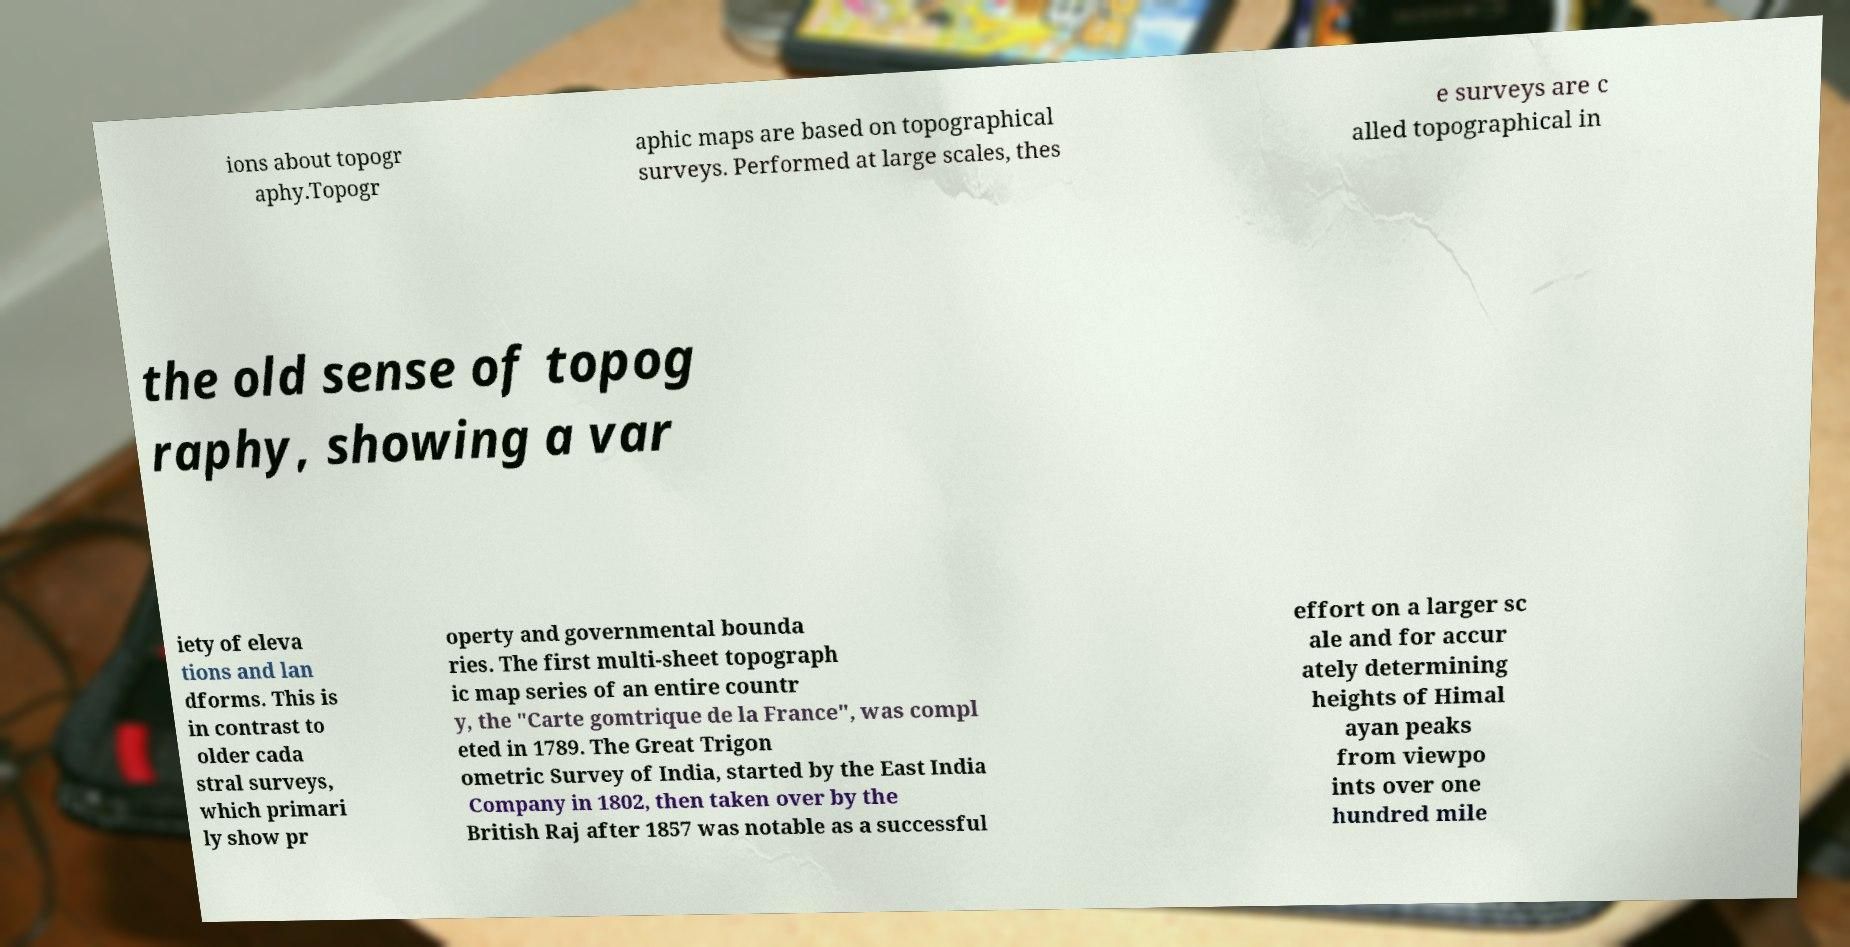Please identify and transcribe the text found in this image. ions about topogr aphy.Topogr aphic maps are based on topographical surveys. Performed at large scales, thes e surveys are c alled topographical in the old sense of topog raphy, showing a var iety of eleva tions and lan dforms. This is in contrast to older cada stral surveys, which primari ly show pr operty and governmental bounda ries. The first multi-sheet topograph ic map series of an entire countr y, the "Carte gomtrique de la France", was compl eted in 1789. The Great Trigon ometric Survey of India, started by the East India Company in 1802, then taken over by the British Raj after 1857 was notable as a successful effort on a larger sc ale and for accur ately determining heights of Himal ayan peaks from viewpo ints over one hundred mile 